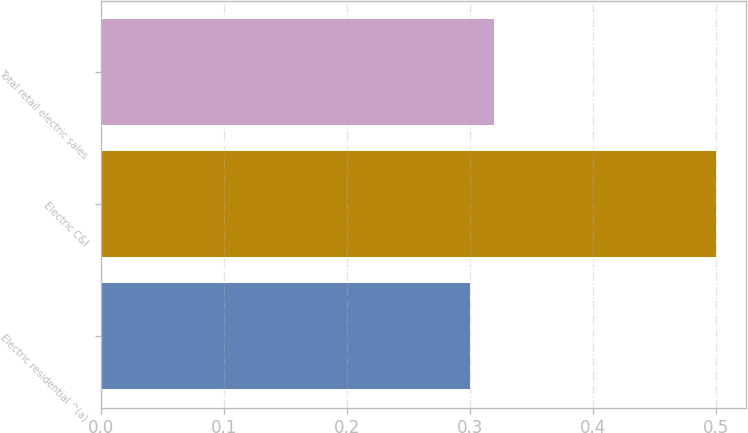<chart> <loc_0><loc_0><loc_500><loc_500><bar_chart><fcel>Electric residential ^(a)<fcel>Electric C&I<fcel>Total retail electric sales<nl><fcel>0.3<fcel>0.5<fcel>0.32<nl></chart> 